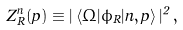Convert formula to latex. <formula><loc_0><loc_0><loc_500><loc_500>Z ^ { n } _ { R } ( { p } ) \equiv | \left < \Omega | \phi _ { R } | n , { p } \right > | ^ { 2 } \, ,</formula> 